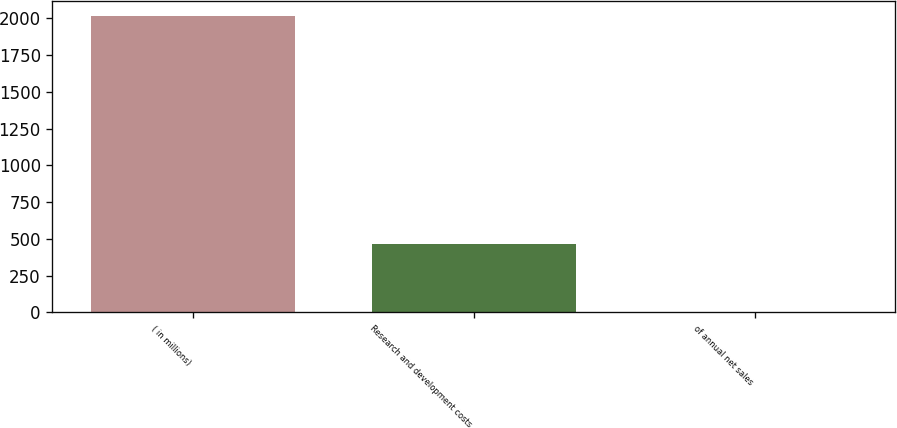<chart> <loc_0><loc_0><loc_500><loc_500><bar_chart><fcel>( in millions)<fcel>Research and development costs<fcel>of annual net sales<nl><fcel>2018<fcel>464<fcel>3<nl></chart> 